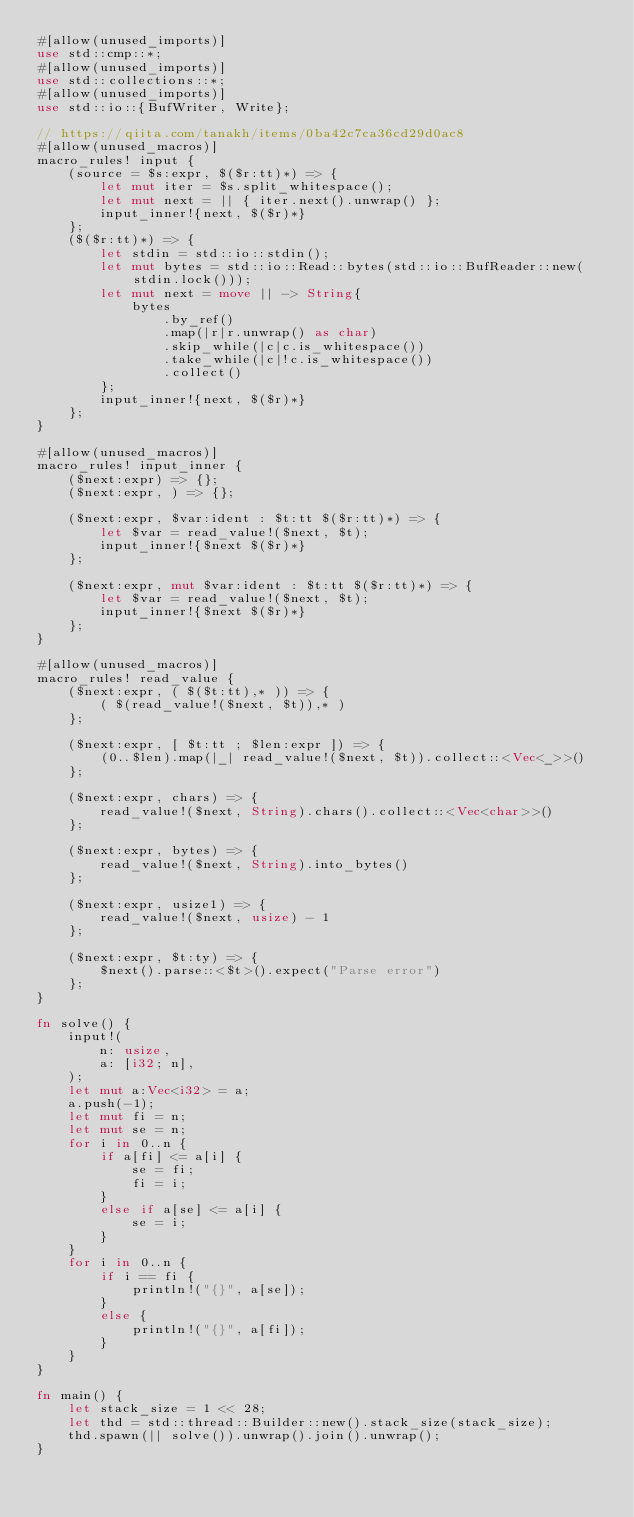Convert code to text. <code><loc_0><loc_0><loc_500><loc_500><_Rust_>#[allow(unused_imports)]
use std::cmp::*;
#[allow(unused_imports)]
use std::collections::*;
#[allow(unused_imports)]
use std::io::{BufWriter, Write};

// https://qiita.com/tanakh/items/0ba42c7ca36cd29d0ac8
#[allow(unused_macros)]
macro_rules! input {
    (source = $s:expr, $($r:tt)*) => {
        let mut iter = $s.split_whitespace();
        let mut next = || { iter.next().unwrap() };
        input_inner!{next, $($r)*}
    };
    ($($r:tt)*) => {
        let stdin = std::io::stdin();
        let mut bytes = std::io::Read::bytes(std::io::BufReader::new(stdin.lock()));
        let mut next = move || -> String{
            bytes
                .by_ref()
                .map(|r|r.unwrap() as char)
                .skip_while(|c|c.is_whitespace())
                .take_while(|c|!c.is_whitespace())
                .collect()
        };
        input_inner!{next, $($r)*}
    };
}

#[allow(unused_macros)]
macro_rules! input_inner {
    ($next:expr) => {};
    ($next:expr, ) => {};

    ($next:expr, $var:ident : $t:tt $($r:tt)*) => {
        let $var = read_value!($next, $t);
        input_inner!{$next $($r)*}
    };

    ($next:expr, mut $var:ident : $t:tt $($r:tt)*) => {
        let $var = read_value!($next, $t);
        input_inner!{$next $($r)*}
    };
}

#[allow(unused_macros)]
macro_rules! read_value {
    ($next:expr, ( $($t:tt),* )) => {
        ( $(read_value!($next, $t)),* )
    };

    ($next:expr, [ $t:tt ; $len:expr ]) => {
        (0..$len).map(|_| read_value!($next, $t)).collect::<Vec<_>>()
    };

    ($next:expr, chars) => {
        read_value!($next, String).chars().collect::<Vec<char>>()
    };

    ($next:expr, bytes) => {
        read_value!($next, String).into_bytes()
    };

    ($next:expr, usize1) => {
        read_value!($next, usize) - 1
    };

    ($next:expr, $t:ty) => {
        $next().parse::<$t>().expect("Parse error")
    };
}

fn solve() {
    input!(
        n: usize,
        a: [i32; n],
    );
    let mut a:Vec<i32> = a;
    a.push(-1);
    let mut fi = n;
    let mut se = n;
    for i in 0..n {
        if a[fi] <= a[i] {
            se = fi;
            fi = i;
        }
        else if a[se] <= a[i] {
            se = i;
        }
    }
    for i in 0..n {
        if i == fi {
            println!("{}", a[se]);
        }
        else {
            println!("{}", a[fi]);
        }
    }
}

fn main() {
    let stack_size = 1 << 28;
    let thd = std::thread::Builder::new().stack_size(stack_size);
    thd.spawn(|| solve()).unwrap().join().unwrap();
}
</code> 